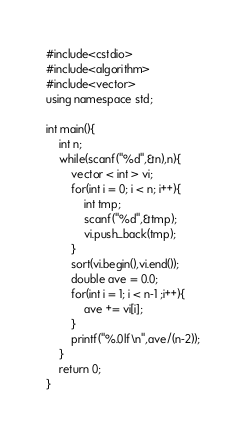<code> <loc_0><loc_0><loc_500><loc_500><_C++_>#include<cstdio>
#include<algorithm>
#include<vector>
using namespace std;

int main(){
	int n;
	while(scanf("%d",&n),n){
		vector < int > vi;
		for(int i = 0; i < n; i++){
			int tmp;
			scanf("%d",&tmp);
			vi.push_back(tmp);
		}
		sort(vi.begin(),vi.end());
		double ave = 0.0;
		for(int i = 1; i < n-1 ;i++){
			ave += vi[i];
		}
		printf("%.0lf\n",ave/(n-2));
	}
	return 0;
}</code> 